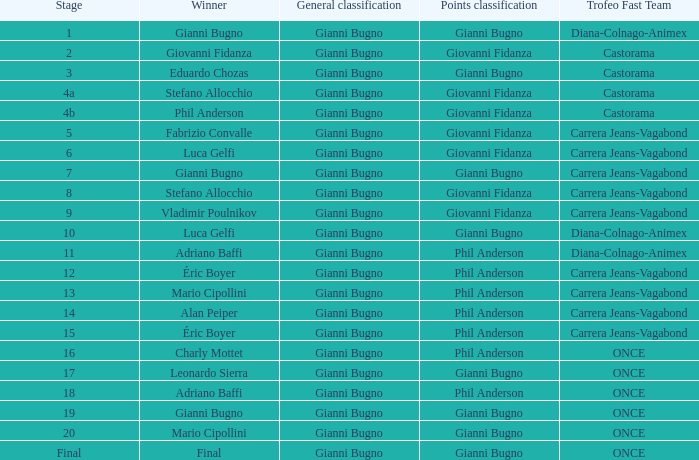What is the stage when the winner is charly mottet? 16.0. 